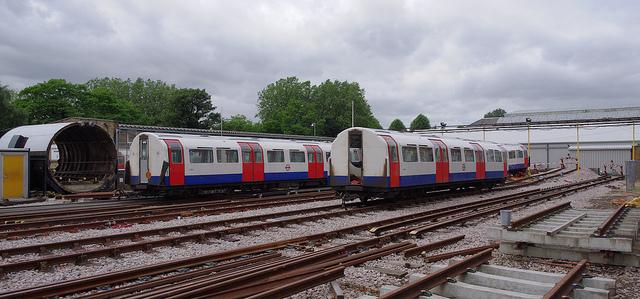How many train cars are there?
Short answer required. 2. Does the train look round?
Short answer required. Yes. Is this day overcast?
Short answer required. Yes. What color are the train doors?
Quick response, please. Red. 